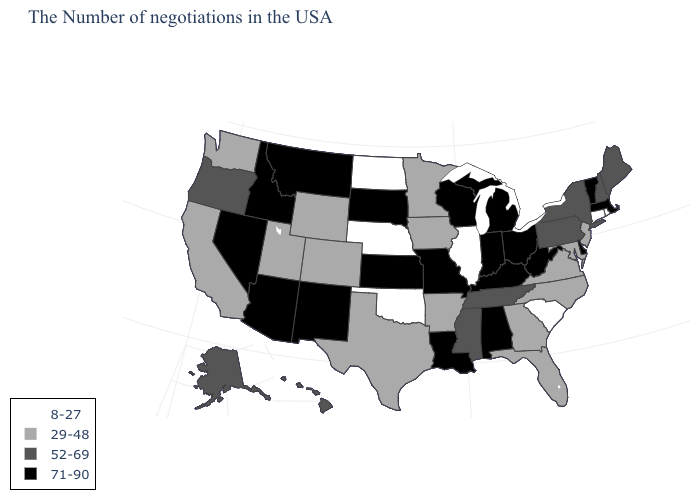What is the value of Connecticut?
Write a very short answer. 8-27. What is the value of Hawaii?
Concise answer only. 52-69. Does Nebraska have the lowest value in the MidWest?
Concise answer only. Yes. Which states have the lowest value in the South?
Concise answer only. South Carolina, Oklahoma. What is the lowest value in the Northeast?
Quick response, please. 8-27. Name the states that have a value in the range 71-90?
Give a very brief answer. Massachusetts, Vermont, Delaware, West Virginia, Ohio, Michigan, Kentucky, Indiana, Alabama, Wisconsin, Louisiana, Missouri, Kansas, South Dakota, New Mexico, Montana, Arizona, Idaho, Nevada. Name the states that have a value in the range 52-69?
Write a very short answer. Maine, New Hampshire, New York, Pennsylvania, Tennessee, Mississippi, Oregon, Alaska, Hawaii. Does Illinois have the lowest value in the MidWest?
Give a very brief answer. Yes. What is the highest value in the USA?
Answer briefly. 71-90. Does Connecticut have the lowest value in the Northeast?
Keep it brief. Yes. Does South Carolina have the same value as Illinois?
Give a very brief answer. Yes. Which states have the highest value in the USA?
Answer briefly. Massachusetts, Vermont, Delaware, West Virginia, Ohio, Michigan, Kentucky, Indiana, Alabama, Wisconsin, Louisiana, Missouri, Kansas, South Dakota, New Mexico, Montana, Arizona, Idaho, Nevada. What is the value of Oregon?
Short answer required. 52-69. What is the value of New Jersey?
Short answer required. 29-48. 